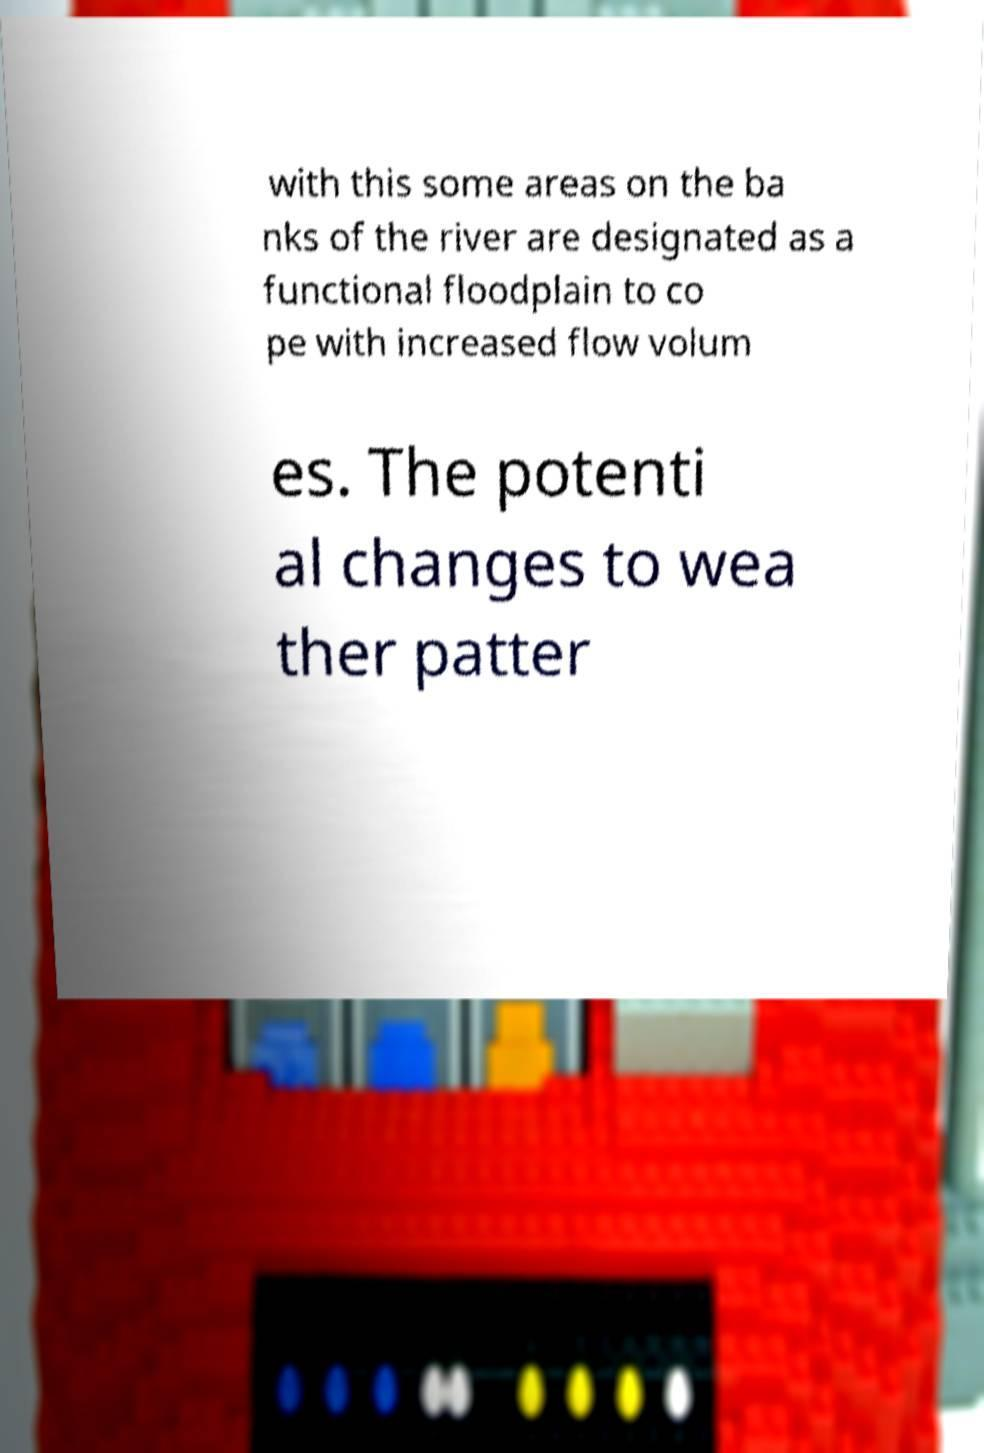Could you assist in decoding the text presented in this image and type it out clearly? with this some areas on the ba nks of the river are designated as a functional floodplain to co pe with increased flow volum es. The potenti al changes to wea ther patter 